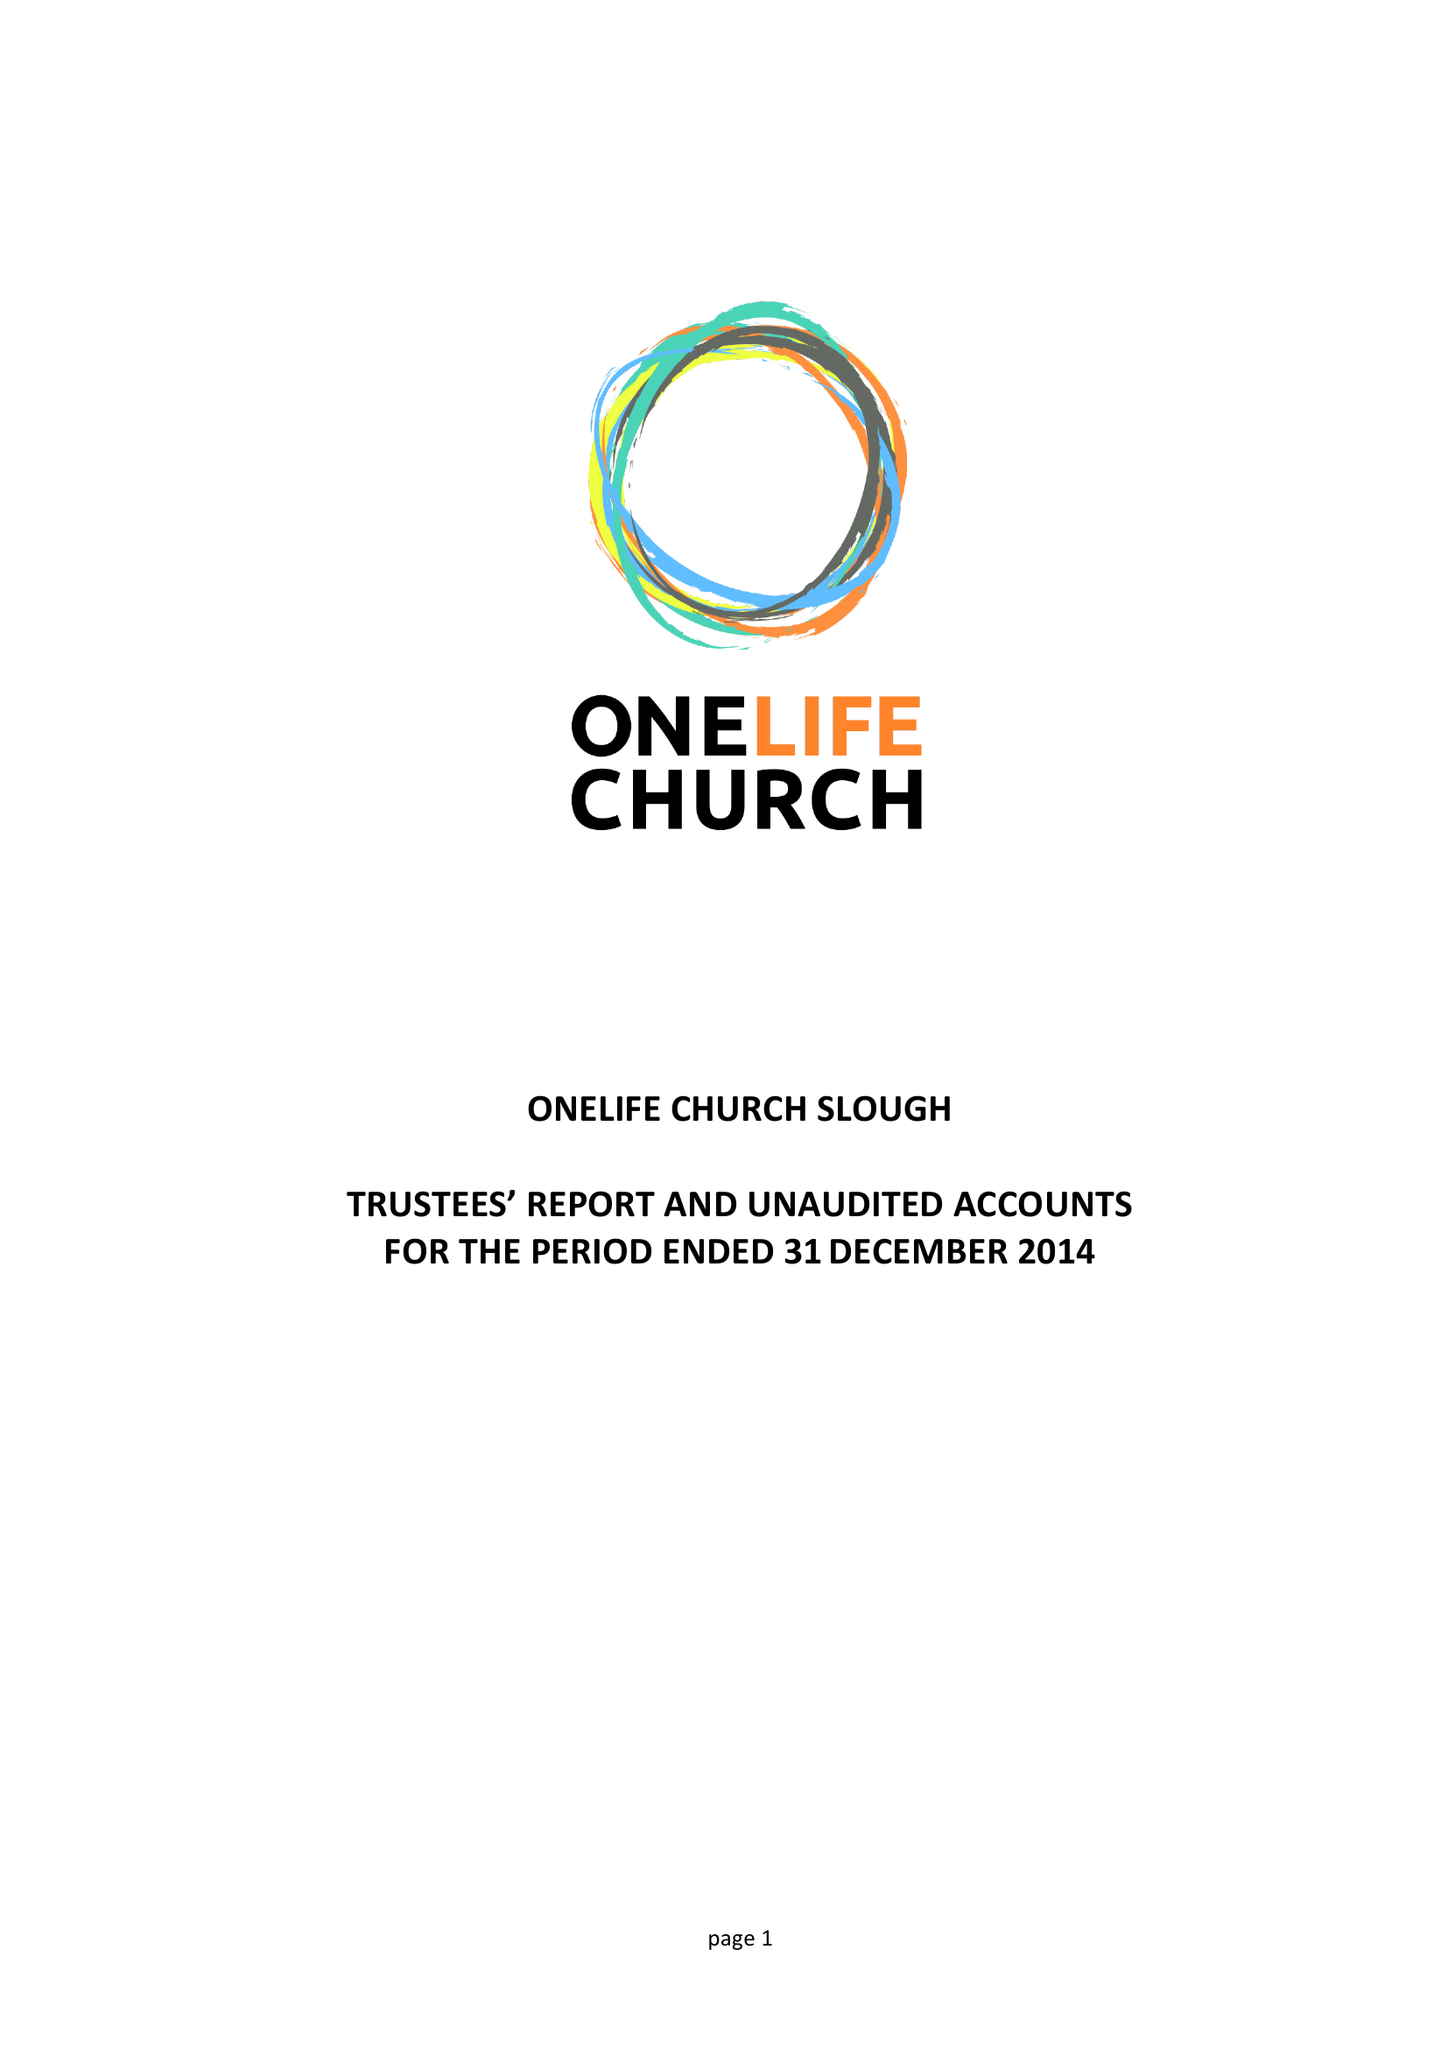What is the value for the spending_annually_in_british_pounds?
Answer the question using a single word or phrase. 10351.00 